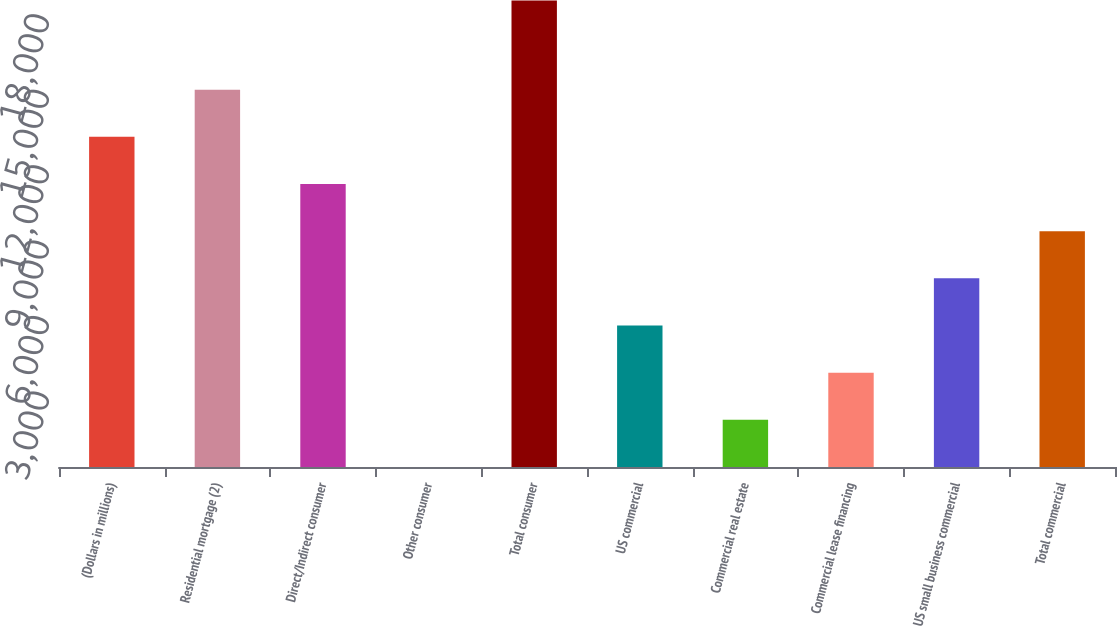Convert chart. <chart><loc_0><loc_0><loc_500><loc_500><bar_chart><fcel>(Dollars in millions)<fcel>Residential mortgage (2)<fcel>Direct/Indirect consumer<fcel>Other consumer<fcel>Total consumer<fcel>US commercial<fcel>Commercial real estate<fcel>Commercial lease financing<fcel>US small business commercial<fcel>Total commercial<nl><fcel>13131.9<fcel>15007.6<fcel>11256.2<fcel>2<fcel>18555<fcel>5629.1<fcel>1877.7<fcel>3753.4<fcel>7504.8<fcel>9380.5<nl></chart> 